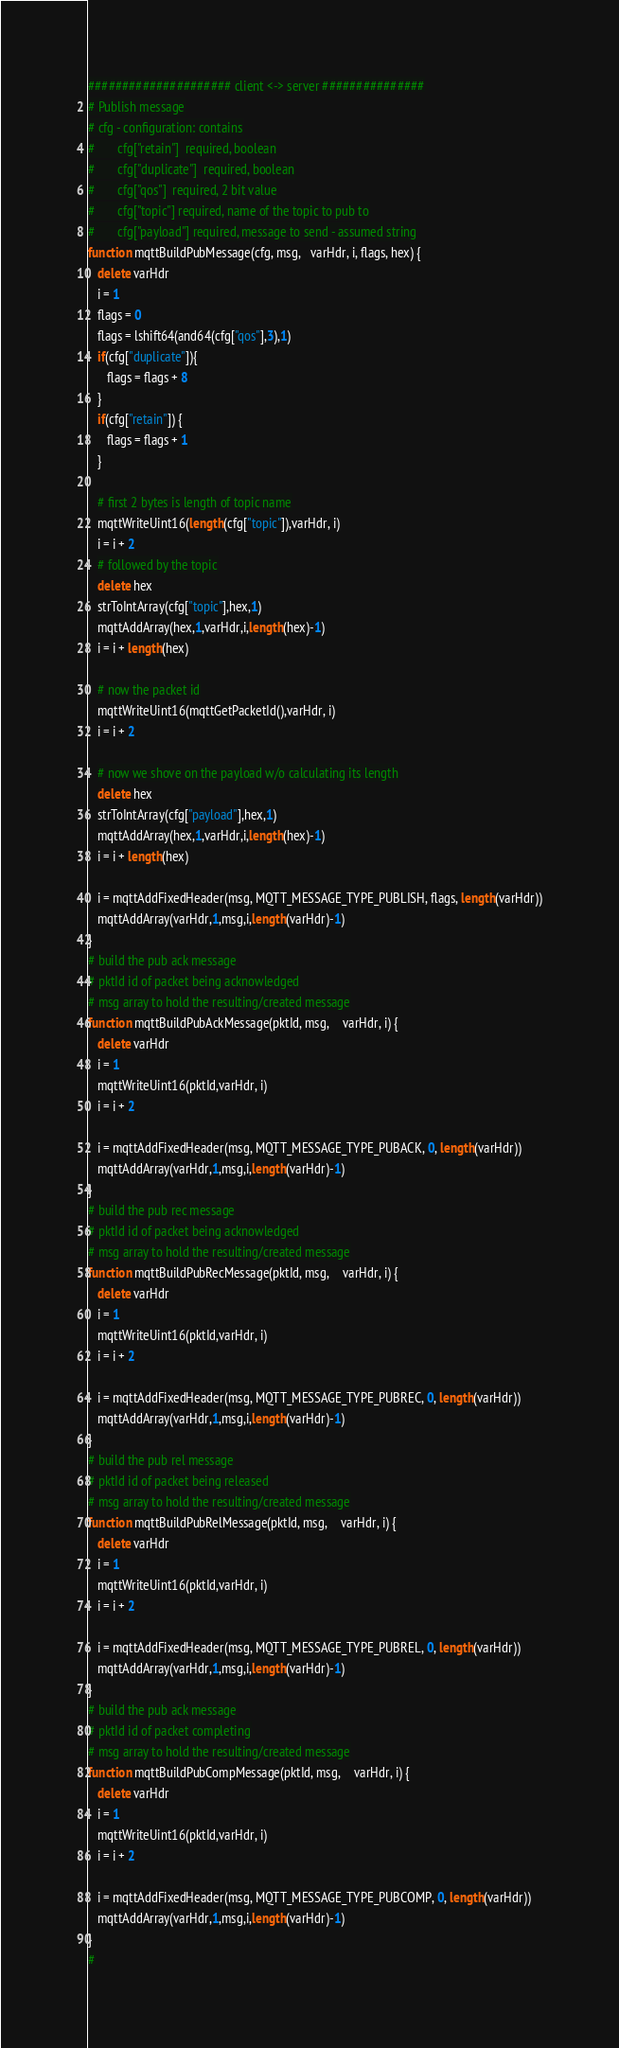Convert code to text. <code><loc_0><loc_0><loc_500><loc_500><_Awk_>##################### client <-> server ###############
# Publish message
# cfg - configuration: contains
#       cfg["retain"]  required, boolean
#       cfg["duplicate"]  required, boolean
#       cfg["qos"]  required, 2 bit value
#       cfg["topic"] required, name of the topic to pub to
#       cfg["payload"] required, message to send - assumed string
function mqttBuildPubMessage(cfg, msg,   varHdr, i, flags, hex) {
   delete varHdr
   i = 1
   flags = 0
   flags = lshift64(and64(cfg["qos"],3),1)
   if(cfg["duplicate"]){
      flags = flags + 8
   }
   if(cfg["retain"]) {
      flags = flags + 1
   }
   
   # first 2 bytes is length of topic name
   mqttWriteUint16(length(cfg["topic"]),varHdr, i)
   i = i + 2
   # followed by the topic
   delete hex
   strToIntArray(cfg["topic"],hex,1)
   mqttAddArray(hex,1,varHdr,i,length(hex)-1)
   i = i + length(hex)
   
   # now the packet id
   mqttWriteUint16(mqttGetPacketId(),varHdr, i)
   i = i + 2
   
   # now we shove on the payload w/o calculating its length
   delete hex
   strToIntArray(cfg["payload"],hex,1)
   mqttAddArray(hex,1,varHdr,i,length(hex)-1)
   i = i + length(hex)
   
   i = mqttAddFixedHeader(msg, MQTT_MESSAGE_TYPE_PUBLISH, flags, length(varHdr))
   mqttAddArray(varHdr,1,msg,i,length(varHdr)-1)   
}
# build the pub ack message
# pktId id of packet being acknowledged
# msg array to hold the resulting/created message
function mqttBuildPubAckMessage(pktId, msg,    varHdr, i) {
   delete varHdr
   i = 1
   mqttWriteUint16(pktId,varHdr, i)
   i = i + 2
   
   i = mqttAddFixedHeader(msg, MQTT_MESSAGE_TYPE_PUBACK, 0, length(varHdr))
   mqttAddArray(varHdr,1,msg,i,length(varHdr)-1)   
}
# build the pub rec message
# pktId id of packet being acknowledged
# msg array to hold the resulting/created message
function mqttBuildPubRecMessage(pktId, msg,    varHdr, i) {
   delete varHdr
   i = 1
   mqttWriteUint16(pktId,varHdr, i)
   i = i + 2
   
   i = mqttAddFixedHeader(msg, MQTT_MESSAGE_TYPE_PUBREC, 0, length(varHdr))
   mqttAddArray(varHdr,1,msg,i,length(varHdr)-1)   
} 
# build the pub rel message
# pktId id of packet being released
# msg array to hold the resulting/created message
function mqttBuildPubRelMessage(pktId, msg,    varHdr, i) {
   delete varHdr
   i = 1
   mqttWriteUint16(pktId,varHdr, i)
   i = i + 2
   
   i = mqttAddFixedHeader(msg, MQTT_MESSAGE_TYPE_PUBREL, 0, length(varHdr))
   mqttAddArray(varHdr,1,msg,i,length(varHdr)-1)   
}  
# build the pub ack message
# pktId id of packet completing
# msg array to hold the resulting/created message
function mqttBuildPubCompMessage(pktId, msg,    varHdr, i) {
   delete varHdr
   i = 1
   mqttWriteUint16(pktId,varHdr, i)
   i = i + 2
   
   i = mqttAddFixedHeader(msg, MQTT_MESSAGE_TYPE_PUBCOMP, 0, length(varHdr))
   mqttAddArray(varHdr,1,msg,i,length(varHdr)-1)   
}  
#
</code> 